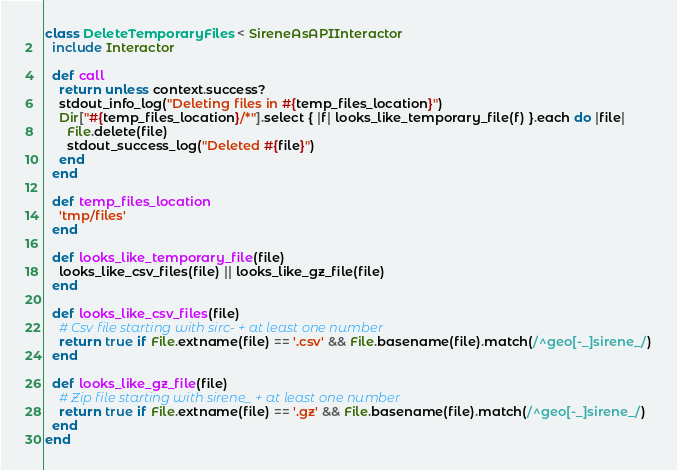<code> <loc_0><loc_0><loc_500><loc_500><_Ruby_>class DeleteTemporaryFiles < SireneAsAPIInteractor
  include Interactor

  def call
    return unless context.success?
    stdout_info_log("Deleting files in #{temp_files_location}")
    Dir["#{temp_files_location}/*"].select { |f| looks_like_temporary_file(f) }.each do |file|
      File.delete(file)
      stdout_success_log("Deleted #{file}")
    end
  end

  def temp_files_location
    'tmp/files'
  end

  def looks_like_temporary_file(file)
    looks_like_csv_files(file) || looks_like_gz_file(file)
  end

  def looks_like_csv_files(file)
    # Csv file starting with sirc- + at least one number
    return true if File.extname(file) == '.csv' && File.basename(file).match(/^geo[-_]sirene_/)
  end

  def looks_like_gz_file(file)
    # Zip file starting with sirene_ + at least one number
    return true if File.extname(file) == '.gz' && File.basename(file).match(/^geo[-_]sirene_/)
  end
end
</code> 